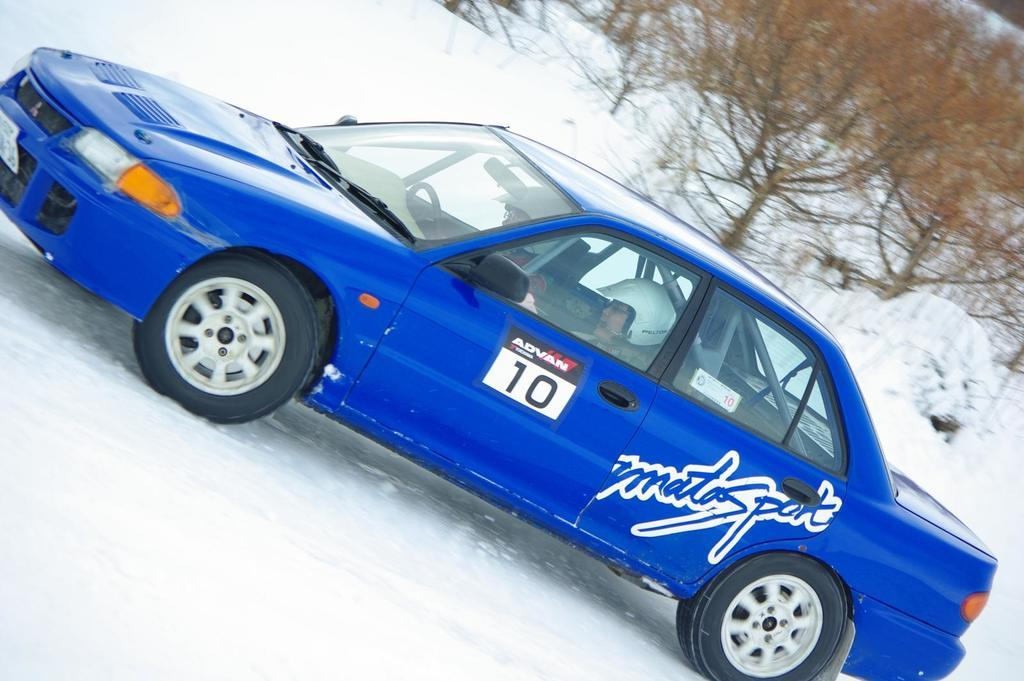What is covering the ground in the image? There is snow on the ground in the image. What is the color of the snow? The snow is white in color. What vehicle is present in the image? There is a car in the image. What colors can be seen on the car? The car is blue, white, and black in color. Where is the car located in the image? The car is on the snow. What can be seen in the background of the image? There are trees in the background of the image. How does the car contribute to pollution in the image? The image does not provide any information about the car's emissions or its impact on pollution. --- Facts: 1. There is a person sitting on a bench in the image. 2. The person is reading a book. 3. The bench is made of wood. 4. There is a tree behind the bench. 5. The tree has green leaves. Absurd Topics: parrot, sand, bicycle Conversation: What is the person in the image doing? The person is sitting on a bench in the image. What activity is the person engaged in while sitting on the bench? The person is reading a book. What material is the bench made of? The bench is made of wood. What can be seen behind the bench in the image? There is a tree behind the bench. What is the condition of the tree's leaves? The tree has green leaves. Reasoning: Let's think step by step in order to produce the conversation. We start by identifying the main subject in the image, which is the person sitting on the bench. Then, we describe the person's activity, which is reading a book. We provide details about the bench's material and location, and finally, we mention the tree behind the bench and its green leaves. Each question is designed to elicit a specific detail about the image that is known from the provided facts. Absurd Question/Answer: What type of parrot is sitting on the bicycle in the image? There is no parrot or bicycle present in the image. 